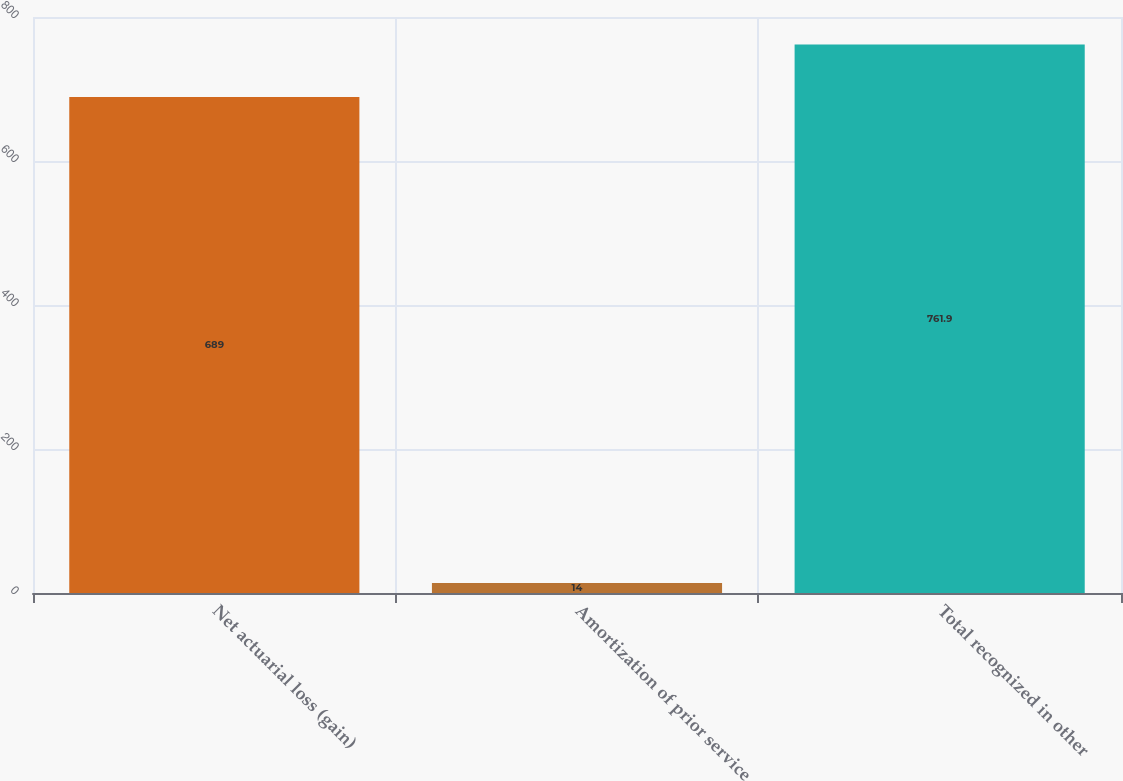Convert chart to OTSL. <chart><loc_0><loc_0><loc_500><loc_500><bar_chart><fcel>Net actuarial loss (gain)<fcel>Amortization of prior service<fcel>Total recognized in other<nl><fcel>689<fcel>14<fcel>761.9<nl></chart> 